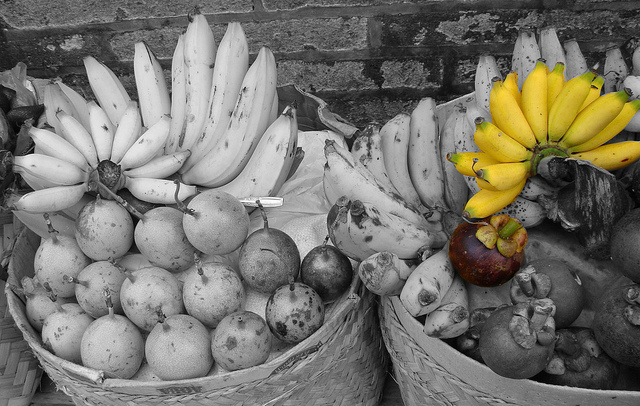Please provide the bounding box coordinate of the region this sentence describes: colored bananas. The region corresponding to 'colored bananas' is located at coordinates [0.69, 0.27, 1.0, 0.52]. 